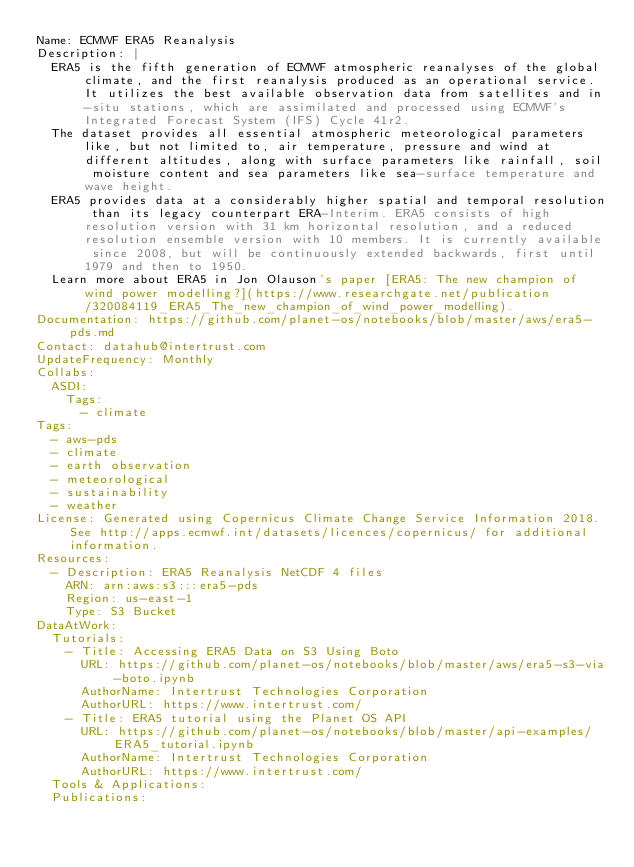<code> <loc_0><loc_0><loc_500><loc_500><_YAML_>Name: ECMWF ERA5 Reanalysis
Description: |
  ERA5 is the fifth generation of ECMWF atmospheric reanalyses of the global climate, and the first reanalysis produced as an operational service. It utilizes the best available observation data from satellites and in-situ stations, which are assimilated and processed using ECMWF's Integrated Forecast System (IFS) Cycle 41r2.
  The dataset provides all essential atmospheric meteorological parameters like, but not limited to, air temperature, pressure and wind at different altitudes, along with surface parameters like rainfall, soil moisture content and sea parameters like sea-surface temperature and wave height.
  ERA5 provides data at a considerably higher spatial and temporal resolution than its legacy counterpart ERA-Interim. ERA5 consists of high resolution version with 31 km horizontal resolution, and a reduced resolution ensemble version with 10 members. It is currently available since 2008, but will be continuously extended backwards, first until 1979 and then to 1950.
  Learn more about ERA5 in Jon Olauson's paper [ERA5: The new champion of wind power modelling?](https://www.researchgate.net/publication/320084119_ERA5_The_new_champion_of_wind_power_modelling).
Documentation: https://github.com/planet-os/notebooks/blob/master/aws/era5-pds.md
Contact: datahub@intertrust.com
UpdateFrequency: Monthly
Collabs:
  ASDI:
    Tags:
      - climate
Tags:
  - aws-pds
  - climate
  - earth observation
  - meteorological
  - sustainability
  - weather
License: Generated using Copernicus Climate Change Service Information 2018. See http://apps.ecmwf.int/datasets/licences/copernicus/ for additional information.
Resources:
  - Description: ERA5 Reanalysis NetCDF 4 files
    ARN: arn:aws:s3:::era5-pds
    Region: us-east-1
    Type: S3 Bucket
DataAtWork:
  Tutorials:
    - Title: Accessing ERA5 Data on S3 Using Boto
      URL: https://github.com/planet-os/notebooks/blob/master/aws/era5-s3-via-boto.ipynb
      AuthorName: Intertrust Technologies Corporation
      AuthorURL: https://www.intertrust.com/
    - Title: ERA5 tutorial using the Planet OS API
      URL: https://github.com/planet-os/notebooks/blob/master/api-examples/ERA5_tutorial.ipynb
      AuthorName: Intertrust Technologies Corporation
      AuthorURL: https://www.intertrust.com/
  Tools & Applications:
  Publications:
</code> 